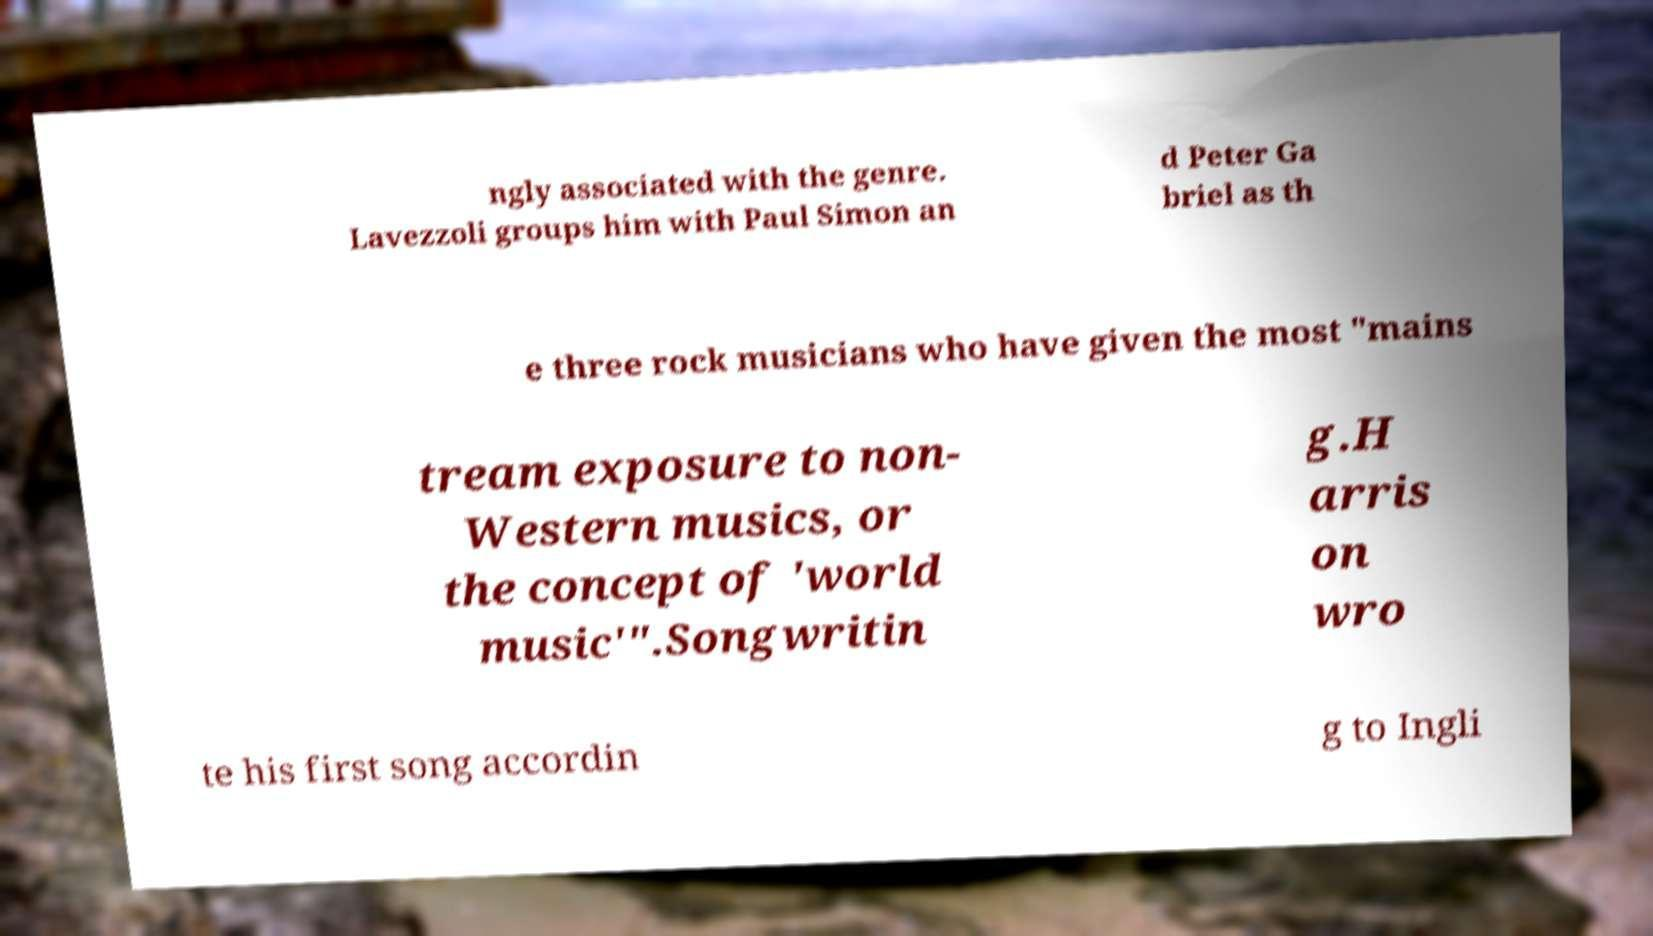Can you read and provide the text displayed in the image?This photo seems to have some interesting text. Can you extract and type it out for me? ngly associated with the genre. Lavezzoli groups him with Paul Simon an d Peter Ga briel as th e three rock musicians who have given the most "mains tream exposure to non- Western musics, or the concept of 'world music'".Songwritin g.H arris on wro te his first song accordin g to Ingli 